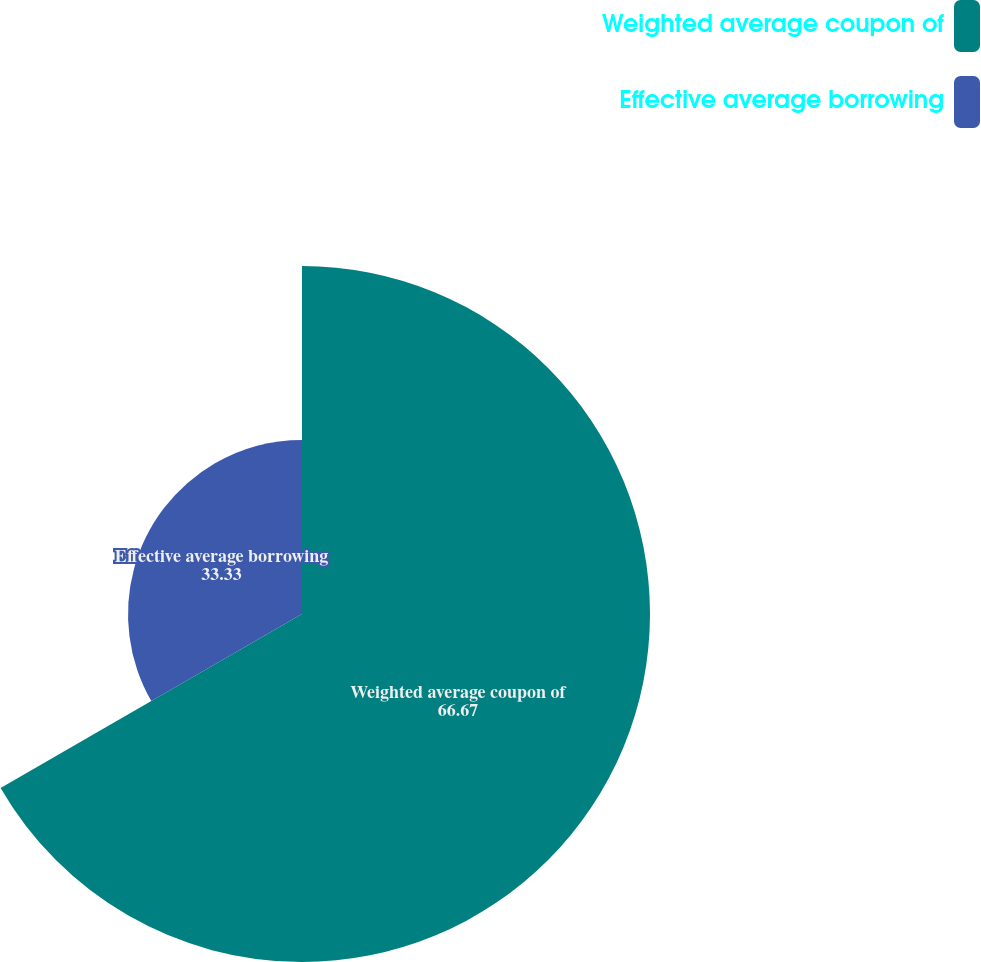Convert chart. <chart><loc_0><loc_0><loc_500><loc_500><pie_chart><fcel>Weighted average coupon of<fcel>Effective average borrowing<nl><fcel>66.67%<fcel>33.33%<nl></chart> 